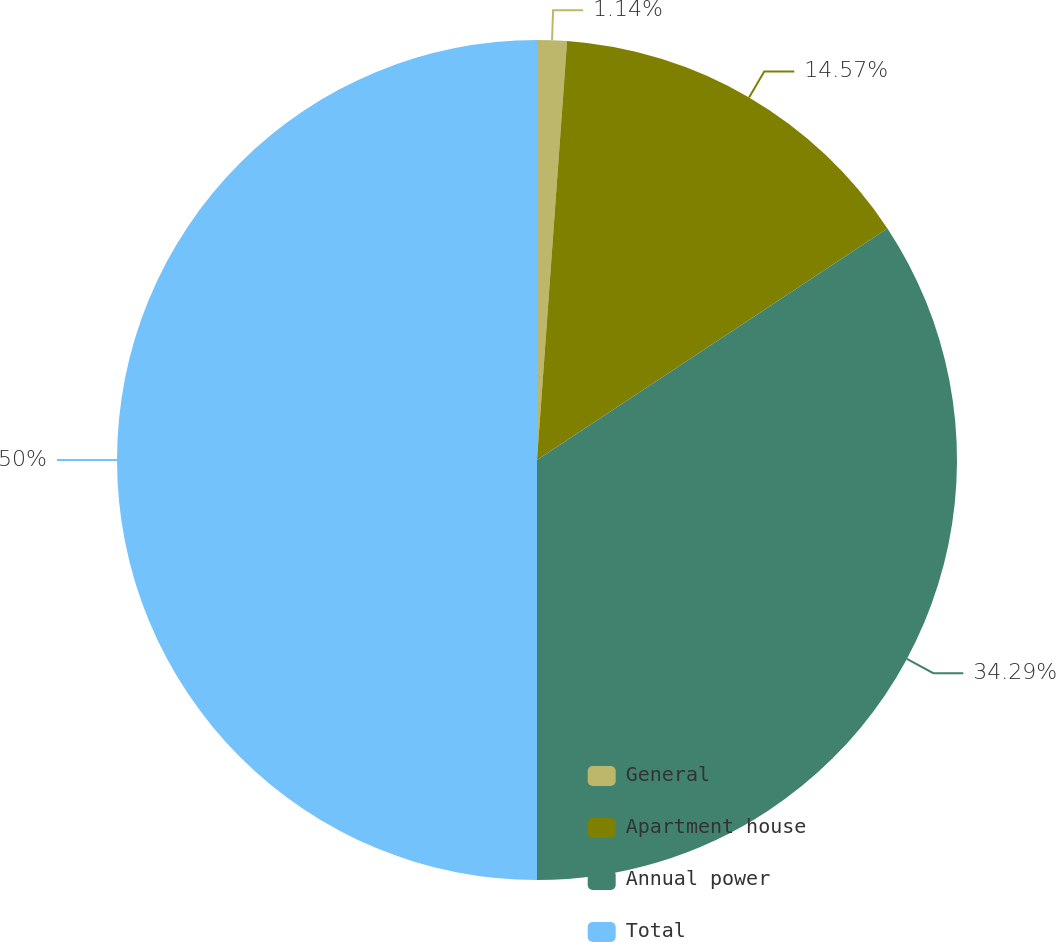Convert chart. <chart><loc_0><loc_0><loc_500><loc_500><pie_chart><fcel>General<fcel>Apartment house<fcel>Annual power<fcel>Total<nl><fcel>1.14%<fcel>14.57%<fcel>34.29%<fcel>50.0%<nl></chart> 